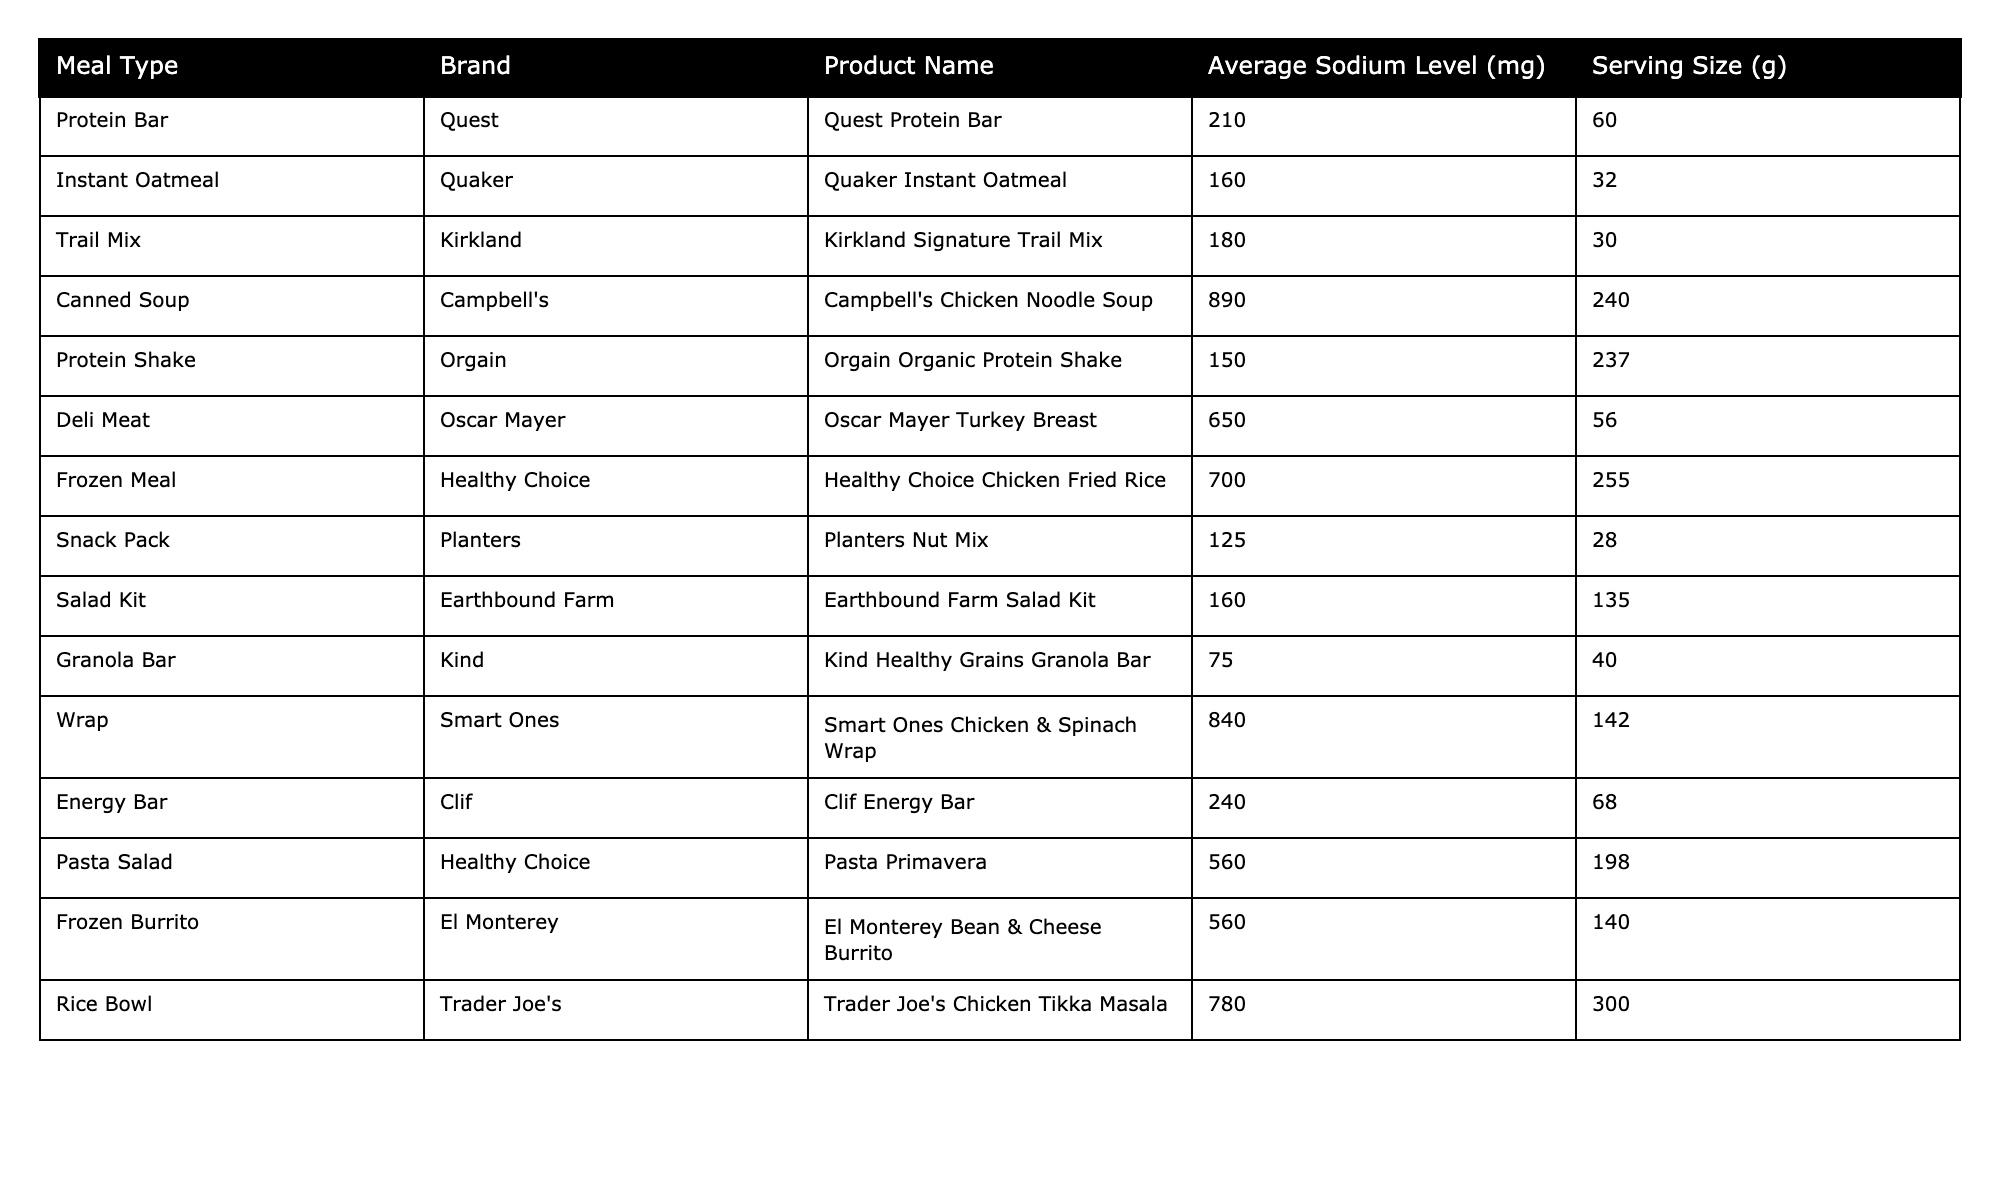What's the highest sodium level in the table? The table lists various meals with their corresponding sodium levels. To find the highest sodium level, I identify the meal with the maximum value. The "Campbell's Chicken Noodle Soup" has a sodium level of 890 mg, which is the highest in the table.
Answer: 890 mg Which meal has the lowest sodium level? To determine the lowest sodium level, I scan the sodium levels from all listed meals. The "Kind Healthy Grains Granola Bar" has the least sodium at 75 mg.
Answer: 75 mg What is the average sodium level for all meals listed? To calculate the average sodium level, I first add up all sodium levels: 210 + 160 + 180 + 890 + 150 + 650 + 700 + 125 + 160 + 75 + 840 + 240 + 560 + 560 + 780 = 5,675 mg. Then, I divide this total by the number of meals, which is 15. Thus, the average sodium level is 5,675 / 15 = 378.33 mg.
Answer: 378.33 mg How many meals have a sodium level above 700 mg? I need to count the number of meals that have a sodium level greater than 700 mg by reviewing the sodium levels. The meals "Canned Soup," "Deli Meat," "Frozen Meal," "Wrap," "Pasta Salad," "Frozen Burrito," and "Rice Bowl" have sodium levels above 700 mg. That totals 7 meals.
Answer: 7 meals Is the sodium level of a "Protein Bar" higher than that of a "Protein Shake"? I compare the sodium levels of the two meals. The "Quest Protein Bar" has 210 mg of sodium, while the "Orgain Organic Protein Shake" has 150 mg. Since 210 mg is greater than 150 mg, the sodium level of the "Protein Bar" is higher.
Answer: Yes What is the difference in sodium levels between the highest and lowest meal? I first identify the highest sodium level, which is 890 mg from the "Campbell's Chicken Noodle Soup," and the lowest at 75 mg from the "Kind Healthy Grains Granola Bar." Next, I find the difference: 890 - 75 = 815 mg.
Answer: 815 mg Which meal type has the highest average sodium? I will categorize the meal types and calculate their average sodium levels. For example, for "Canned Soup," the only entry has 890 mg, for "Deli Meat" it's 650 mg, for "Frozen Meals" it’s 700 mg, etc. After calculating the averages, the "Canned Soup" with 890 mg stands out as the highest average sodium level since it has only one entry.
Answer: Canned Soup How many products have sodium levels below 200 mg? I examine the sodium levels to see which of them fall below 200 mg. The meals with sodium levels below 200 mg are the "Instant Oatmeal," "Trail Mix," "Protein Shake," "Snack Pack," "Salad Kit," and "Granola Bar." There are 6 products in total.
Answer: 6 products Are there any meals with sodium levels of 500 mg or more? I look for any entries with sodium levels at or above 500 mg. The meals that meet this criterion are "Canned Soup," "Deli Meat," "Frozen Meal," "Wrap," "Pasta Salad," "Frozen Burrito," and "Rice Bowl." Thus, there are meals above this threshold.
Answer: Yes What meal has the sodium level closest to 300 mg? I check the sodium levels to find the closest value to 300 mg. The "Rice Bowl" has 780 mg and the "Protein Shake" has 150 mg, while the "Frozen Burrito" has 560 mg. The "Rice Bowl" is the farthest, so I evaluate and find no meal directly at 300 mg. The "Pasta Salad" at 560 mg is the closest to 300 mg.
Answer: Frozen Burrito 